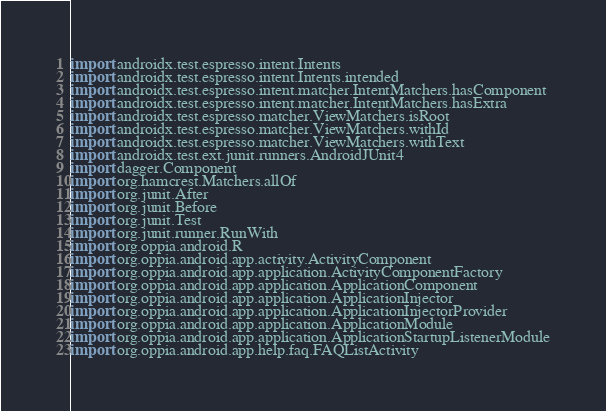<code> <loc_0><loc_0><loc_500><loc_500><_Kotlin_>import androidx.test.espresso.intent.Intents
import androidx.test.espresso.intent.Intents.intended
import androidx.test.espresso.intent.matcher.IntentMatchers.hasComponent
import androidx.test.espresso.intent.matcher.IntentMatchers.hasExtra
import androidx.test.espresso.matcher.ViewMatchers.isRoot
import androidx.test.espresso.matcher.ViewMatchers.withId
import androidx.test.espresso.matcher.ViewMatchers.withText
import androidx.test.ext.junit.runners.AndroidJUnit4
import dagger.Component
import org.hamcrest.Matchers.allOf
import org.junit.After
import org.junit.Before
import org.junit.Test
import org.junit.runner.RunWith
import org.oppia.android.R
import org.oppia.android.app.activity.ActivityComponent
import org.oppia.android.app.application.ActivityComponentFactory
import org.oppia.android.app.application.ApplicationComponent
import org.oppia.android.app.application.ApplicationInjector
import org.oppia.android.app.application.ApplicationInjectorProvider
import org.oppia.android.app.application.ApplicationModule
import org.oppia.android.app.application.ApplicationStartupListenerModule
import org.oppia.android.app.help.faq.FAQListActivity</code> 